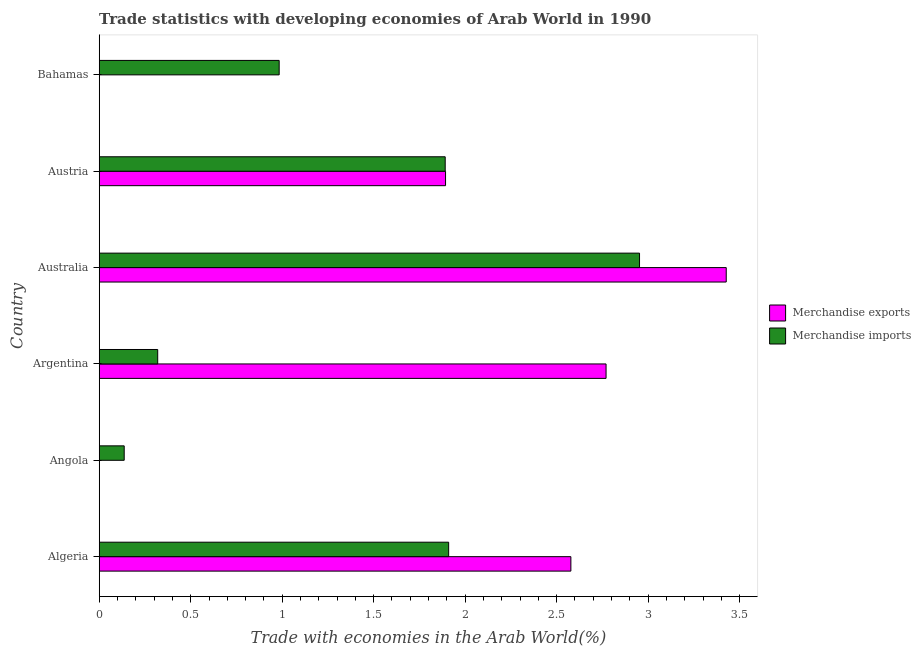How many different coloured bars are there?
Offer a very short reply. 2. Are the number of bars on each tick of the Y-axis equal?
Your response must be concise. Yes. How many bars are there on the 2nd tick from the top?
Keep it short and to the point. 2. In how many cases, is the number of bars for a given country not equal to the number of legend labels?
Provide a succinct answer. 0. What is the merchandise exports in Australia?
Give a very brief answer. 3.43. Across all countries, what is the maximum merchandise imports?
Provide a short and direct response. 2.95. Across all countries, what is the minimum merchandise exports?
Provide a short and direct response. 3.04411132647725e-5. In which country was the merchandise imports minimum?
Your answer should be compact. Angola. What is the total merchandise exports in the graph?
Make the answer very short. 10.67. What is the difference between the merchandise imports in Angola and that in Australia?
Make the answer very short. -2.82. What is the difference between the merchandise imports in Australia and the merchandise exports in Bahamas?
Make the answer very short. 2.95. What is the average merchandise imports per country?
Your answer should be compact. 1.36. What is the difference between the merchandise exports and merchandise imports in Australia?
Ensure brevity in your answer.  0.47. In how many countries, is the merchandise imports greater than 3.2 %?
Offer a very short reply. 0. What is the ratio of the merchandise imports in Algeria to that in Bahamas?
Provide a succinct answer. 1.94. Is the merchandise exports in Algeria less than that in Bahamas?
Make the answer very short. No. What is the difference between the highest and the second highest merchandise exports?
Keep it short and to the point. 0.66. What is the difference between the highest and the lowest merchandise imports?
Give a very brief answer. 2.82. Is the sum of the merchandise imports in Argentina and Austria greater than the maximum merchandise exports across all countries?
Make the answer very short. No. What does the 1st bar from the top in Bahamas represents?
Provide a succinct answer. Merchandise imports. Are all the bars in the graph horizontal?
Give a very brief answer. Yes. What is the difference between two consecutive major ticks on the X-axis?
Make the answer very short. 0.5. Are the values on the major ticks of X-axis written in scientific E-notation?
Your answer should be compact. No. Where does the legend appear in the graph?
Ensure brevity in your answer.  Center right. How many legend labels are there?
Give a very brief answer. 2. What is the title of the graph?
Make the answer very short. Trade statistics with developing economies of Arab World in 1990. What is the label or title of the X-axis?
Offer a very short reply. Trade with economies in the Arab World(%). What is the label or title of the Y-axis?
Make the answer very short. Country. What is the Trade with economies in the Arab World(%) of Merchandise exports in Algeria?
Offer a terse response. 2.58. What is the Trade with economies in the Arab World(%) in Merchandise imports in Algeria?
Make the answer very short. 1.91. What is the Trade with economies in the Arab World(%) of Merchandise exports in Angola?
Keep it short and to the point. 3.04411132647725e-5. What is the Trade with economies in the Arab World(%) in Merchandise imports in Angola?
Provide a succinct answer. 0.14. What is the Trade with economies in the Arab World(%) in Merchandise exports in Argentina?
Your response must be concise. 2.77. What is the Trade with economies in the Arab World(%) of Merchandise imports in Argentina?
Your response must be concise. 0.32. What is the Trade with economies in the Arab World(%) in Merchandise exports in Australia?
Offer a terse response. 3.43. What is the Trade with economies in the Arab World(%) in Merchandise imports in Australia?
Your answer should be very brief. 2.95. What is the Trade with economies in the Arab World(%) of Merchandise exports in Austria?
Give a very brief answer. 1.89. What is the Trade with economies in the Arab World(%) in Merchandise imports in Austria?
Provide a succinct answer. 1.89. What is the Trade with economies in the Arab World(%) in Merchandise exports in Bahamas?
Your answer should be very brief. 0. What is the Trade with economies in the Arab World(%) in Merchandise imports in Bahamas?
Offer a very short reply. 0.98. Across all countries, what is the maximum Trade with economies in the Arab World(%) in Merchandise exports?
Make the answer very short. 3.43. Across all countries, what is the maximum Trade with economies in the Arab World(%) of Merchandise imports?
Offer a terse response. 2.95. Across all countries, what is the minimum Trade with economies in the Arab World(%) in Merchandise exports?
Provide a short and direct response. 3.04411132647725e-5. Across all countries, what is the minimum Trade with economies in the Arab World(%) of Merchandise imports?
Provide a short and direct response. 0.14. What is the total Trade with economies in the Arab World(%) of Merchandise exports in the graph?
Give a very brief answer. 10.67. What is the total Trade with economies in the Arab World(%) of Merchandise imports in the graph?
Provide a short and direct response. 8.19. What is the difference between the Trade with economies in the Arab World(%) of Merchandise exports in Algeria and that in Angola?
Keep it short and to the point. 2.58. What is the difference between the Trade with economies in the Arab World(%) of Merchandise imports in Algeria and that in Angola?
Your answer should be very brief. 1.77. What is the difference between the Trade with economies in the Arab World(%) in Merchandise exports in Algeria and that in Argentina?
Offer a terse response. -0.19. What is the difference between the Trade with economies in the Arab World(%) of Merchandise imports in Algeria and that in Argentina?
Your answer should be very brief. 1.59. What is the difference between the Trade with economies in the Arab World(%) in Merchandise exports in Algeria and that in Australia?
Your response must be concise. -0.85. What is the difference between the Trade with economies in the Arab World(%) of Merchandise imports in Algeria and that in Australia?
Make the answer very short. -1.04. What is the difference between the Trade with economies in the Arab World(%) in Merchandise exports in Algeria and that in Austria?
Provide a succinct answer. 0.68. What is the difference between the Trade with economies in the Arab World(%) in Merchandise imports in Algeria and that in Austria?
Offer a terse response. 0.02. What is the difference between the Trade with economies in the Arab World(%) in Merchandise exports in Algeria and that in Bahamas?
Ensure brevity in your answer.  2.58. What is the difference between the Trade with economies in the Arab World(%) in Merchandise imports in Algeria and that in Bahamas?
Provide a short and direct response. 0.93. What is the difference between the Trade with economies in the Arab World(%) of Merchandise exports in Angola and that in Argentina?
Ensure brevity in your answer.  -2.77. What is the difference between the Trade with economies in the Arab World(%) of Merchandise imports in Angola and that in Argentina?
Keep it short and to the point. -0.18. What is the difference between the Trade with economies in the Arab World(%) of Merchandise exports in Angola and that in Australia?
Offer a very short reply. -3.43. What is the difference between the Trade with economies in the Arab World(%) in Merchandise imports in Angola and that in Australia?
Your answer should be very brief. -2.82. What is the difference between the Trade with economies in the Arab World(%) of Merchandise exports in Angola and that in Austria?
Make the answer very short. -1.89. What is the difference between the Trade with economies in the Arab World(%) in Merchandise imports in Angola and that in Austria?
Make the answer very short. -1.75. What is the difference between the Trade with economies in the Arab World(%) of Merchandise exports in Angola and that in Bahamas?
Give a very brief answer. -0. What is the difference between the Trade with economies in the Arab World(%) of Merchandise imports in Angola and that in Bahamas?
Your answer should be very brief. -0.85. What is the difference between the Trade with economies in the Arab World(%) of Merchandise exports in Argentina and that in Australia?
Provide a short and direct response. -0.66. What is the difference between the Trade with economies in the Arab World(%) of Merchandise imports in Argentina and that in Australia?
Your answer should be compact. -2.63. What is the difference between the Trade with economies in the Arab World(%) of Merchandise exports in Argentina and that in Austria?
Your response must be concise. 0.88. What is the difference between the Trade with economies in the Arab World(%) of Merchandise imports in Argentina and that in Austria?
Give a very brief answer. -1.57. What is the difference between the Trade with economies in the Arab World(%) in Merchandise exports in Argentina and that in Bahamas?
Your answer should be compact. 2.77. What is the difference between the Trade with economies in the Arab World(%) of Merchandise imports in Argentina and that in Bahamas?
Your response must be concise. -0.66. What is the difference between the Trade with economies in the Arab World(%) of Merchandise exports in Australia and that in Austria?
Provide a succinct answer. 1.53. What is the difference between the Trade with economies in the Arab World(%) in Merchandise imports in Australia and that in Austria?
Make the answer very short. 1.06. What is the difference between the Trade with economies in the Arab World(%) of Merchandise exports in Australia and that in Bahamas?
Provide a succinct answer. 3.43. What is the difference between the Trade with economies in the Arab World(%) of Merchandise imports in Australia and that in Bahamas?
Your response must be concise. 1.97. What is the difference between the Trade with economies in the Arab World(%) of Merchandise exports in Austria and that in Bahamas?
Provide a succinct answer. 1.89. What is the difference between the Trade with economies in the Arab World(%) in Merchandise imports in Austria and that in Bahamas?
Offer a very short reply. 0.91. What is the difference between the Trade with economies in the Arab World(%) of Merchandise exports in Algeria and the Trade with economies in the Arab World(%) of Merchandise imports in Angola?
Provide a succinct answer. 2.44. What is the difference between the Trade with economies in the Arab World(%) in Merchandise exports in Algeria and the Trade with economies in the Arab World(%) in Merchandise imports in Argentina?
Offer a terse response. 2.26. What is the difference between the Trade with economies in the Arab World(%) of Merchandise exports in Algeria and the Trade with economies in the Arab World(%) of Merchandise imports in Australia?
Provide a short and direct response. -0.38. What is the difference between the Trade with economies in the Arab World(%) in Merchandise exports in Algeria and the Trade with economies in the Arab World(%) in Merchandise imports in Austria?
Make the answer very short. 0.69. What is the difference between the Trade with economies in the Arab World(%) of Merchandise exports in Algeria and the Trade with economies in the Arab World(%) of Merchandise imports in Bahamas?
Provide a short and direct response. 1.59. What is the difference between the Trade with economies in the Arab World(%) in Merchandise exports in Angola and the Trade with economies in the Arab World(%) in Merchandise imports in Argentina?
Offer a very short reply. -0.32. What is the difference between the Trade with economies in the Arab World(%) in Merchandise exports in Angola and the Trade with economies in the Arab World(%) in Merchandise imports in Australia?
Make the answer very short. -2.95. What is the difference between the Trade with economies in the Arab World(%) in Merchandise exports in Angola and the Trade with economies in the Arab World(%) in Merchandise imports in Austria?
Keep it short and to the point. -1.89. What is the difference between the Trade with economies in the Arab World(%) in Merchandise exports in Angola and the Trade with economies in the Arab World(%) in Merchandise imports in Bahamas?
Offer a terse response. -0.98. What is the difference between the Trade with economies in the Arab World(%) in Merchandise exports in Argentina and the Trade with economies in the Arab World(%) in Merchandise imports in Australia?
Give a very brief answer. -0.18. What is the difference between the Trade with economies in the Arab World(%) of Merchandise exports in Argentina and the Trade with economies in the Arab World(%) of Merchandise imports in Austria?
Keep it short and to the point. 0.88. What is the difference between the Trade with economies in the Arab World(%) of Merchandise exports in Argentina and the Trade with economies in the Arab World(%) of Merchandise imports in Bahamas?
Your response must be concise. 1.79. What is the difference between the Trade with economies in the Arab World(%) of Merchandise exports in Australia and the Trade with economies in the Arab World(%) of Merchandise imports in Austria?
Your answer should be very brief. 1.54. What is the difference between the Trade with economies in the Arab World(%) of Merchandise exports in Australia and the Trade with economies in the Arab World(%) of Merchandise imports in Bahamas?
Offer a very short reply. 2.44. What is the difference between the Trade with economies in the Arab World(%) of Merchandise exports in Austria and the Trade with economies in the Arab World(%) of Merchandise imports in Bahamas?
Give a very brief answer. 0.91. What is the average Trade with economies in the Arab World(%) in Merchandise exports per country?
Your answer should be very brief. 1.78. What is the average Trade with economies in the Arab World(%) in Merchandise imports per country?
Offer a terse response. 1.37. What is the difference between the Trade with economies in the Arab World(%) in Merchandise exports and Trade with economies in the Arab World(%) in Merchandise imports in Algeria?
Your response must be concise. 0.67. What is the difference between the Trade with economies in the Arab World(%) in Merchandise exports and Trade with economies in the Arab World(%) in Merchandise imports in Angola?
Provide a succinct answer. -0.14. What is the difference between the Trade with economies in the Arab World(%) in Merchandise exports and Trade with economies in the Arab World(%) in Merchandise imports in Argentina?
Your answer should be very brief. 2.45. What is the difference between the Trade with economies in the Arab World(%) of Merchandise exports and Trade with economies in the Arab World(%) of Merchandise imports in Australia?
Ensure brevity in your answer.  0.47. What is the difference between the Trade with economies in the Arab World(%) in Merchandise exports and Trade with economies in the Arab World(%) in Merchandise imports in Austria?
Give a very brief answer. 0. What is the difference between the Trade with economies in the Arab World(%) of Merchandise exports and Trade with economies in the Arab World(%) of Merchandise imports in Bahamas?
Offer a very short reply. -0.98. What is the ratio of the Trade with economies in the Arab World(%) in Merchandise exports in Algeria to that in Angola?
Your response must be concise. 8.47e+04. What is the ratio of the Trade with economies in the Arab World(%) in Merchandise imports in Algeria to that in Angola?
Offer a very short reply. 13.98. What is the ratio of the Trade with economies in the Arab World(%) in Merchandise exports in Algeria to that in Argentina?
Your response must be concise. 0.93. What is the ratio of the Trade with economies in the Arab World(%) in Merchandise imports in Algeria to that in Argentina?
Your answer should be compact. 5.97. What is the ratio of the Trade with economies in the Arab World(%) of Merchandise exports in Algeria to that in Australia?
Offer a very short reply. 0.75. What is the ratio of the Trade with economies in the Arab World(%) of Merchandise imports in Algeria to that in Australia?
Keep it short and to the point. 0.65. What is the ratio of the Trade with economies in the Arab World(%) in Merchandise exports in Algeria to that in Austria?
Make the answer very short. 1.36. What is the ratio of the Trade with economies in the Arab World(%) of Merchandise imports in Algeria to that in Austria?
Offer a terse response. 1.01. What is the ratio of the Trade with economies in the Arab World(%) of Merchandise exports in Algeria to that in Bahamas?
Your response must be concise. 2266.94. What is the ratio of the Trade with economies in the Arab World(%) of Merchandise imports in Algeria to that in Bahamas?
Ensure brevity in your answer.  1.94. What is the ratio of the Trade with economies in the Arab World(%) of Merchandise imports in Angola to that in Argentina?
Offer a terse response. 0.43. What is the ratio of the Trade with economies in the Arab World(%) of Merchandise imports in Angola to that in Australia?
Your answer should be compact. 0.05. What is the ratio of the Trade with economies in the Arab World(%) in Merchandise imports in Angola to that in Austria?
Ensure brevity in your answer.  0.07. What is the ratio of the Trade with economies in the Arab World(%) of Merchandise exports in Angola to that in Bahamas?
Your answer should be very brief. 0.03. What is the ratio of the Trade with economies in the Arab World(%) in Merchandise imports in Angola to that in Bahamas?
Offer a terse response. 0.14. What is the ratio of the Trade with economies in the Arab World(%) in Merchandise exports in Argentina to that in Australia?
Give a very brief answer. 0.81. What is the ratio of the Trade with economies in the Arab World(%) of Merchandise imports in Argentina to that in Australia?
Your answer should be very brief. 0.11. What is the ratio of the Trade with economies in the Arab World(%) in Merchandise exports in Argentina to that in Austria?
Your answer should be very brief. 1.46. What is the ratio of the Trade with economies in the Arab World(%) of Merchandise imports in Argentina to that in Austria?
Keep it short and to the point. 0.17. What is the ratio of the Trade with economies in the Arab World(%) of Merchandise exports in Argentina to that in Bahamas?
Make the answer very short. 2436.05. What is the ratio of the Trade with economies in the Arab World(%) of Merchandise imports in Argentina to that in Bahamas?
Your answer should be very brief. 0.33. What is the ratio of the Trade with economies in the Arab World(%) in Merchandise exports in Australia to that in Austria?
Your answer should be compact. 1.81. What is the ratio of the Trade with economies in the Arab World(%) in Merchandise imports in Australia to that in Austria?
Give a very brief answer. 1.56. What is the ratio of the Trade with economies in the Arab World(%) of Merchandise exports in Australia to that in Bahamas?
Your answer should be very brief. 3013.63. What is the ratio of the Trade with economies in the Arab World(%) of Merchandise imports in Australia to that in Bahamas?
Provide a succinct answer. 3. What is the ratio of the Trade with economies in the Arab World(%) of Merchandise exports in Austria to that in Bahamas?
Your answer should be very brief. 1664.58. What is the ratio of the Trade with economies in the Arab World(%) of Merchandise imports in Austria to that in Bahamas?
Provide a succinct answer. 1.92. What is the difference between the highest and the second highest Trade with economies in the Arab World(%) of Merchandise exports?
Offer a very short reply. 0.66. What is the difference between the highest and the second highest Trade with economies in the Arab World(%) of Merchandise imports?
Ensure brevity in your answer.  1.04. What is the difference between the highest and the lowest Trade with economies in the Arab World(%) in Merchandise exports?
Offer a very short reply. 3.43. What is the difference between the highest and the lowest Trade with economies in the Arab World(%) in Merchandise imports?
Provide a short and direct response. 2.82. 